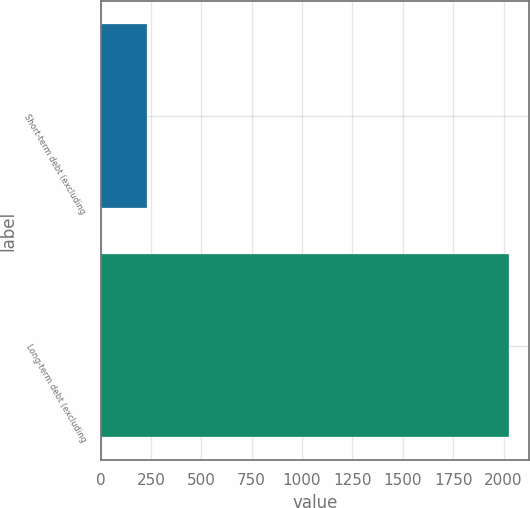<chart> <loc_0><loc_0><loc_500><loc_500><bar_chart><fcel>Short-term debt (excluding<fcel>Long-term debt (excluding<nl><fcel>230<fcel>2025<nl></chart> 